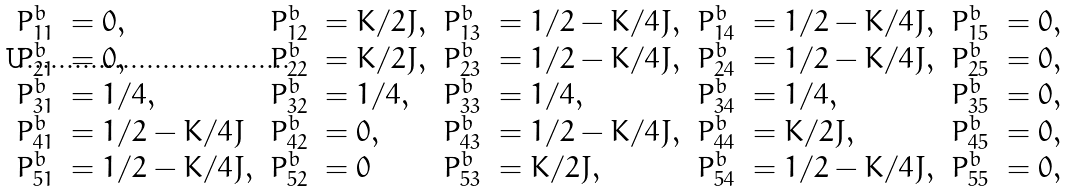<formula> <loc_0><loc_0><loc_500><loc_500>\begin{array} { l l } P ^ { b } _ { 1 1 } & = 0 , \\ P ^ { b } _ { 2 1 } & = 0 , \\ P ^ { b } _ { 3 1 } & = 1 / 4 , \\ P ^ { b } _ { 4 1 } & = 1 / 2 - K / 4 J \\ P ^ { b } _ { 5 1 } & = 1 / 2 - K / 4 J , \end{array} \begin{array} { l l } P ^ { b } _ { 1 2 } & = K / 2 J , \\ P ^ { b } _ { 2 2 } & = K / 2 J , \\ P ^ { b } _ { 3 2 } & = 1 / 4 , \\ P ^ { b } _ { 4 2 } & = 0 , \\ P ^ { b } _ { 5 2 } & = 0 \end{array} \begin{array} { l l } P ^ { b } _ { 1 3 } & = 1 / 2 - K / 4 J , \\ P ^ { b } _ { 2 3 } & = 1 / 2 - K / 4 J , \\ P ^ { b } _ { 3 3 } & = 1 / 4 , \\ P ^ { b } _ { 4 3 } & = 1 / 2 - K / 4 J , \\ P ^ { b } _ { 5 3 } & = K / 2 J , \end{array} \begin{array} { l l } P ^ { b } _ { 1 4 } & = 1 / 2 - K / 4 J , \\ P ^ { b } _ { 2 4 } & = 1 / 2 - K / 4 J , \\ P ^ { b } _ { 3 4 } & = 1 / 4 , \\ P ^ { b } _ { 4 4 } & = K / 2 J , \\ P ^ { b } _ { 5 4 } & = 1 / 2 - K / 4 J , \end{array} \begin{array} { l l } P ^ { b } _ { 1 5 } & = 0 , \\ P ^ { b } _ { 2 5 } & = 0 , \\ P ^ { b } _ { 3 5 } & = 0 , \\ P ^ { b } _ { 4 5 } & = 0 , \\ P ^ { b } _ { 5 5 } & = 0 , \end{array}</formula> 